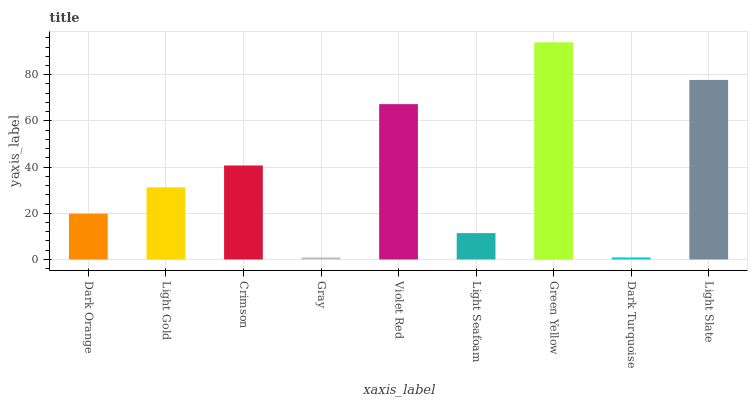Is Gray the minimum?
Answer yes or no. Yes. Is Green Yellow the maximum?
Answer yes or no. Yes. Is Light Gold the minimum?
Answer yes or no. No. Is Light Gold the maximum?
Answer yes or no. No. Is Light Gold greater than Dark Orange?
Answer yes or no. Yes. Is Dark Orange less than Light Gold?
Answer yes or no. Yes. Is Dark Orange greater than Light Gold?
Answer yes or no. No. Is Light Gold less than Dark Orange?
Answer yes or no. No. Is Light Gold the high median?
Answer yes or no. Yes. Is Light Gold the low median?
Answer yes or no. Yes. Is Light Seafoam the high median?
Answer yes or no. No. Is Violet Red the low median?
Answer yes or no. No. 